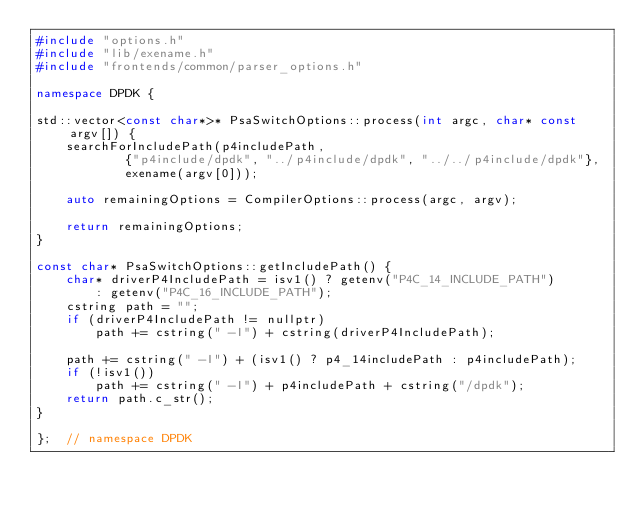Convert code to text. <code><loc_0><loc_0><loc_500><loc_500><_C++_>#include "options.h"
#include "lib/exename.h"
#include "frontends/common/parser_options.h"

namespace DPDK {

std::vector<const char*>* PsaSwitchOptions::process(int argc, char* const argv[]) {
    searchForIncludePath(p4includePath,
            {"p4include/dpdk", "../p4include/dpdk", "../../p4include/dpdk"},
            exename(argv[0]));

    auto remainingOptions = CompilerOptions::process(argc, argv);

    return remainingOptions;
}

const char* PsaSwitchOptions::getIncludePath() {
    char* driverP4IncludePath = isv1() ? getenv("P4C_14_INCLUDE_PATH")
        : getenv("P4C_16_INCLUDE_PATH");
    cstring path = "";
    if (driverP4IncludePath != nullptr)
        path += cstring(" -I") + cstring(driverP4IncludePath);

    path += cstring(" -I") + (isv1() ? p4_14includePath : p4includePath);
    if (!isv1())
        path += cstring(" -I") + p4includePath + cstring("/dpdk");
    return path.c_str();
}

};  // namespace DPDK
</code> 